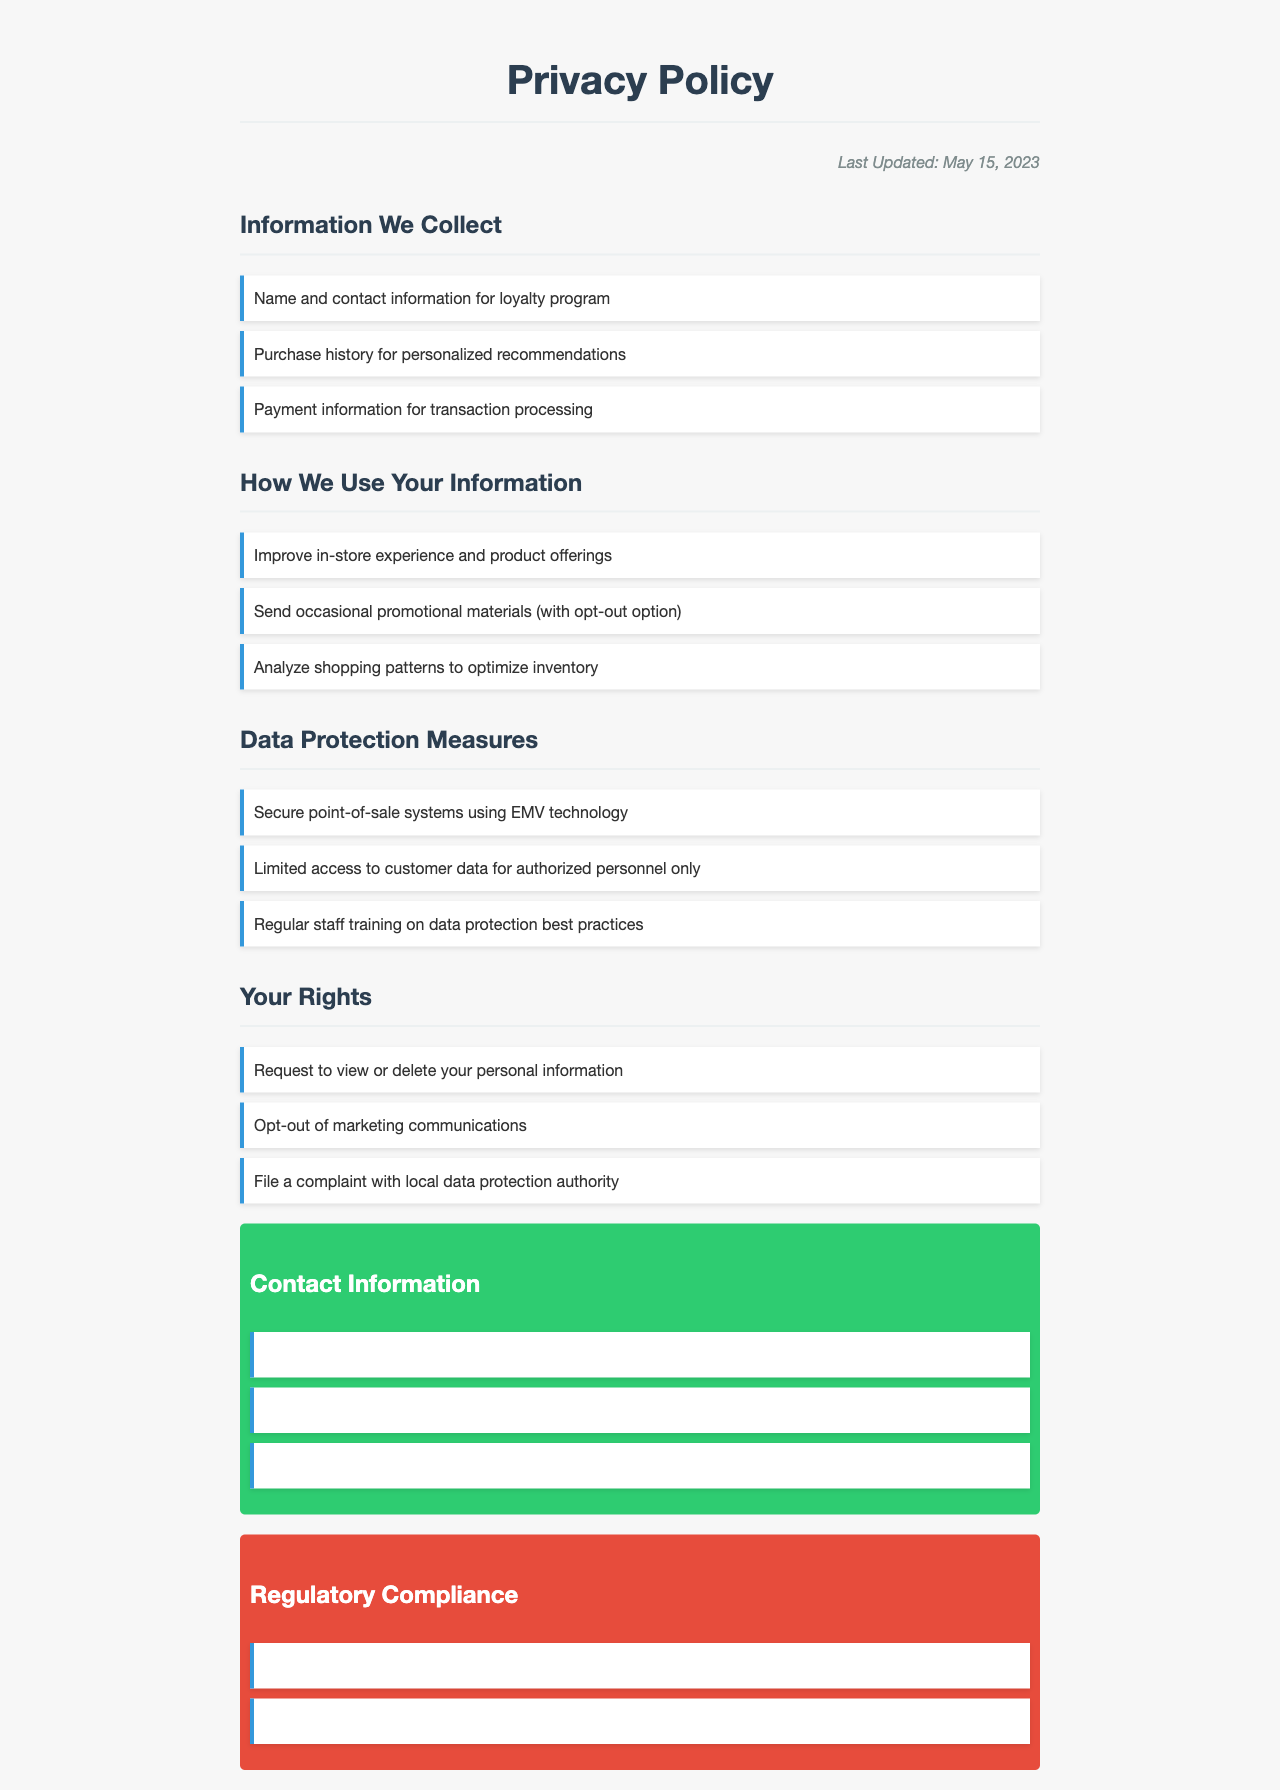What information do we collect for the loyalty program? The document states that we collect "Name and contact information for loyalty program".
Answer: Name and contact information What payment technology is used for security? The document mentions the use of "Secure point-of-sale systems using EMV technology".
Answer: EMV technology When was the privacy policy last updated? The last updated date is explicitly mentioned as "May 15, 2023".
Answer: May 15, 2023 What are customers allowed to do with their personal information? The policy outlines that customers can "Request to view or delete your personal information".
Answer: Request to view or delete How do we analyze shopping patterns? The document states that we analyze shopping patterns "to optimize inventory".
Answer: To optimize inventory What is the email contact for privacy inquiries? The document provides one specific email for privacy inquiries: "privacy@minimalistessentials.com".
Answer: privacy@minimalistessentials.com What type of training is done for staff regarding data protection? It is mentioned that there is "Regular staff training on data protection best practices".
Answer: Regular staff training Which regulatory compliance laws are referenced? The document lists two compliance laws: "California Consumer Privacy Act (CCPA)" and "General Data Protection Regulation (GDPR)".
Answer: CCPA, GDPR 